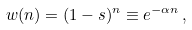Convert formula to latex. <formula><loc_0><loc_0><loc_500><loc_500>w ( n ) = ( 1 - s ) ^ { n } \equiv e ^ { - \alpha n } \, ,</formula> 